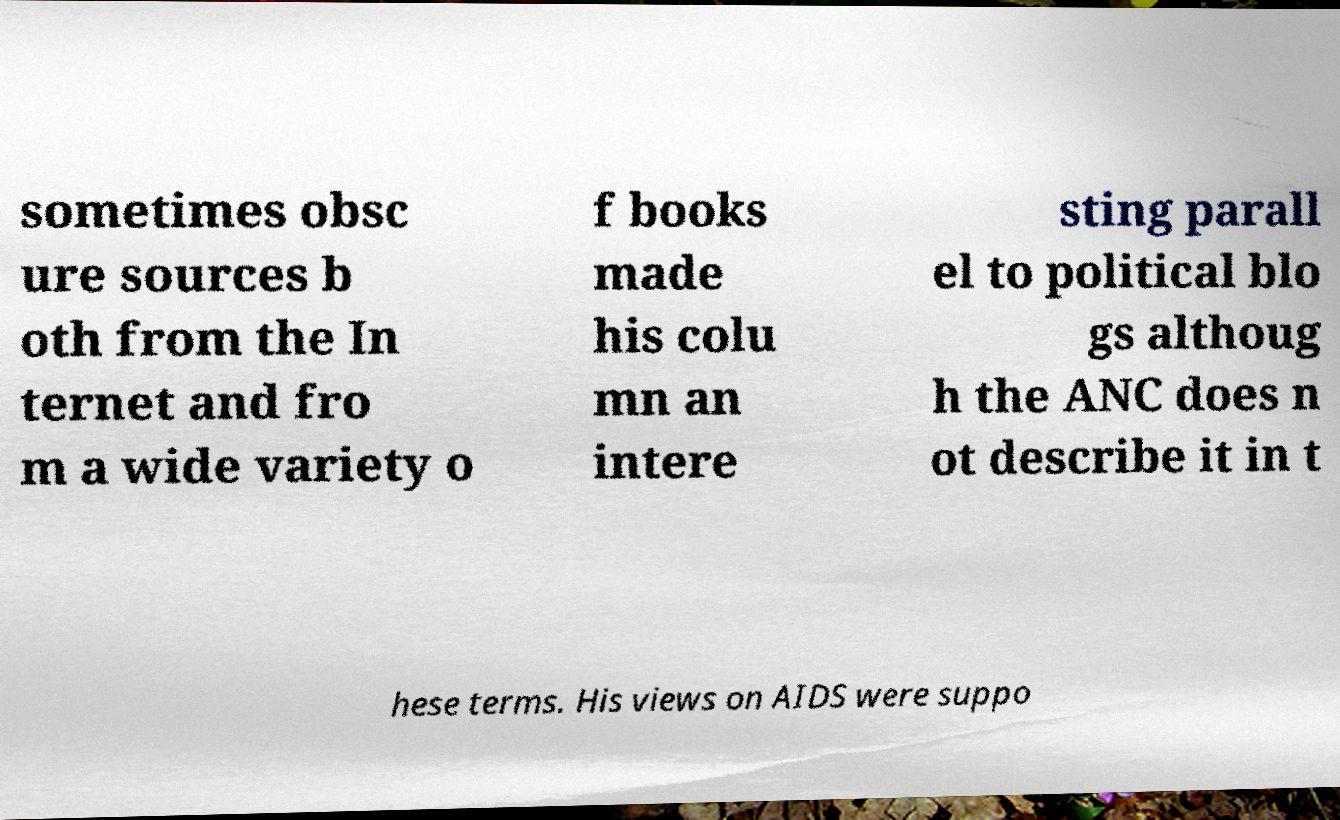Please read and relay the text visible in this image. What does it say? sometimes obsc ure sources b oth from the In ternet and fro m a wide variety o f books made his colu mn an intere sting parall el to political blo gs althoug h the ANC does n ot describe it in t hese terms. His views on AIDS were suppo 